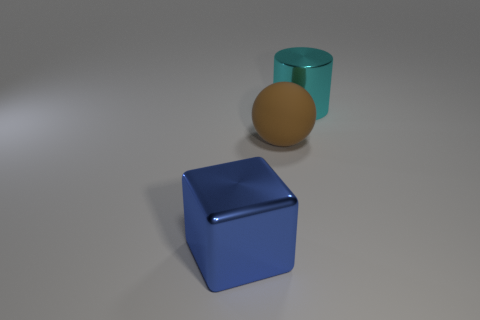Add 3 big metallic cylinders. How many objects exist? 6 Subtract all spheres. How many objects are left? 2 Subtract 0 gray cylinders. How many objects are left? 3 Subtract all spheres. Subtract all matte things. How many objects are left? 1 Add 2 shiny things. How many shiny things are left? 4 Add 1 blue metal cubes. How many blue metal cubes exist? 2 